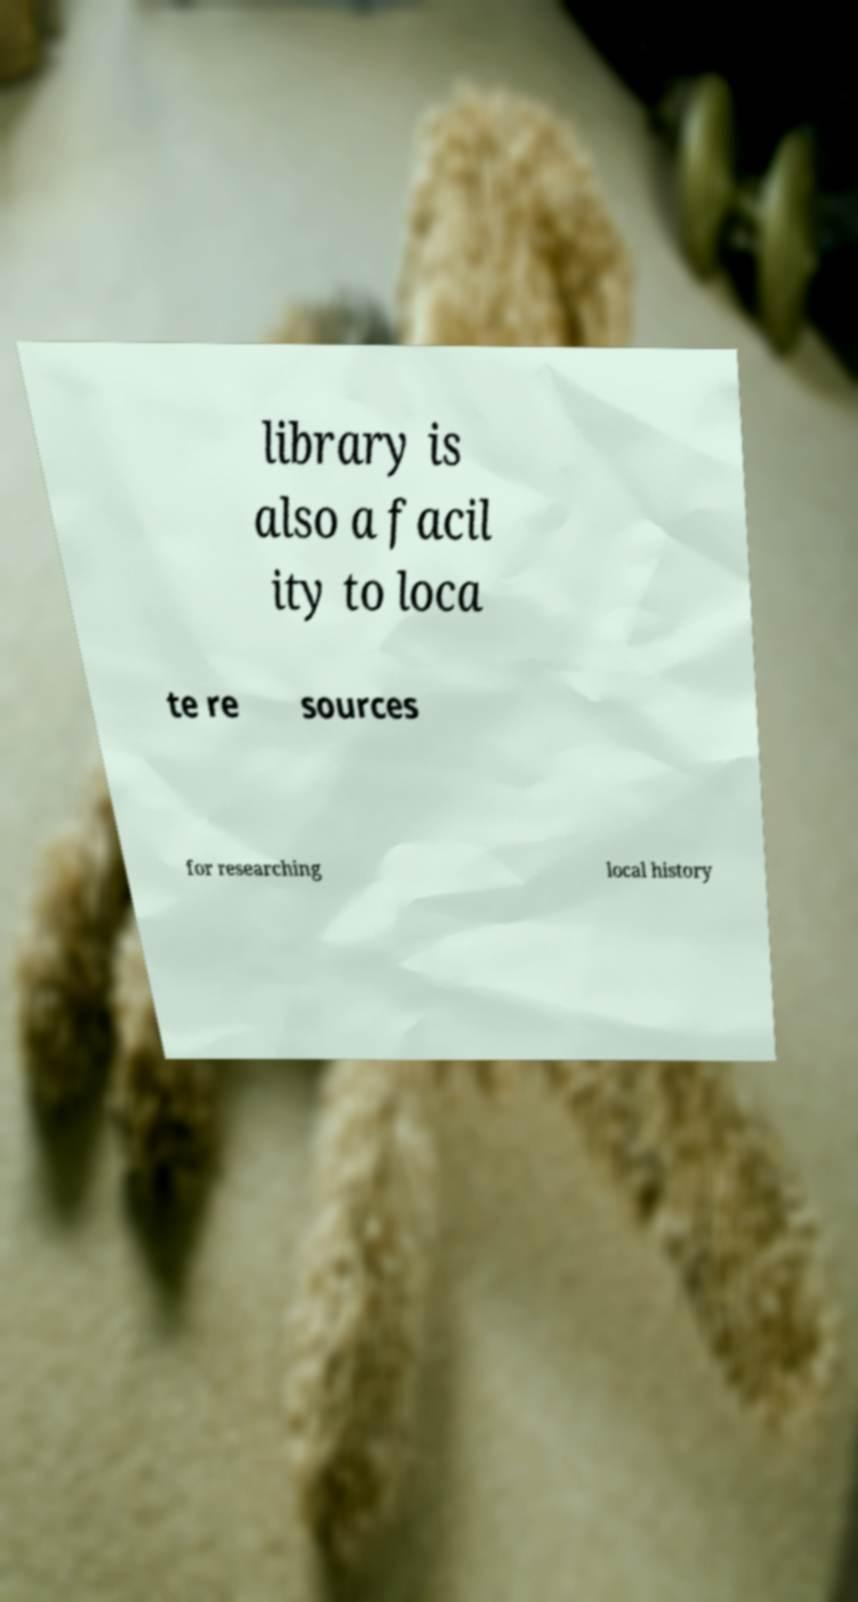Can you read and provide the text displayed in the image?This photo seems to have some interesting text. Can you extract and type it out for me? library is also a facil ity to loca te re sources for researching local history 